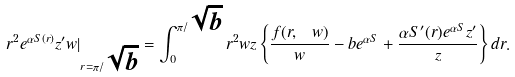Convert formula to latex. <formula><loc_0><loc_0><loc_500><loc_500>r ^ { 2 } e ^ { \alpha S ( r ) } z ^ { \prime } w | _ { r = \pi / \sqrt { b } } = \int _ { 0 } ^ { \pi / \sqrt { b } } r ^ { 2 } w z \left \{ \frac { f ( r , \ w ) } { w } - b e ^ { \alpha S } + \frac { \alpha S ^ { \prime } ( r ) e ^ { \alpha S } z ^ { \prime } } { z } \right \} d r .</formula> 